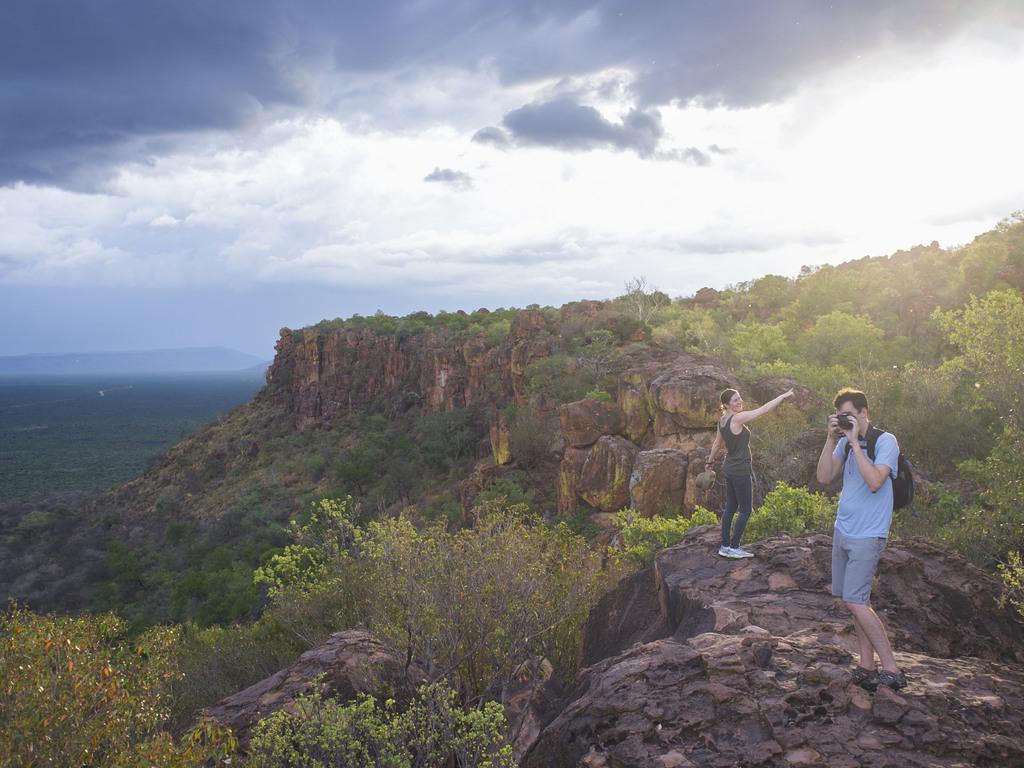Describe this image in one or two sentences. In this image I can see two persons are standing here. I can see one of them is holding a camera and carrying a bag. I can also see number of trees, clouds and the sky in background. 